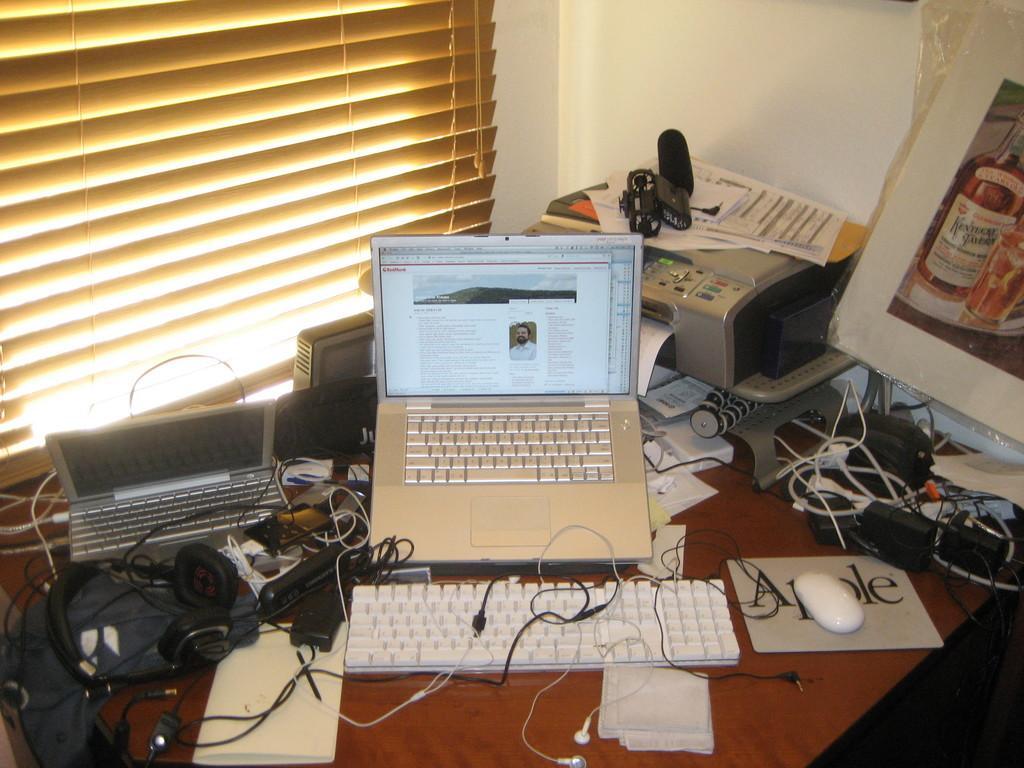Please provide a concise description of this image. In this image, There is a table which is in brown color on that there is a keyboard and laptop which is in white color, There is a mouse in white color, In the left side there is a speaker and headset in black color, There is a laptop in white color, In the right side there is a printer in the white color, In the background there is a window which is in yellow color. 